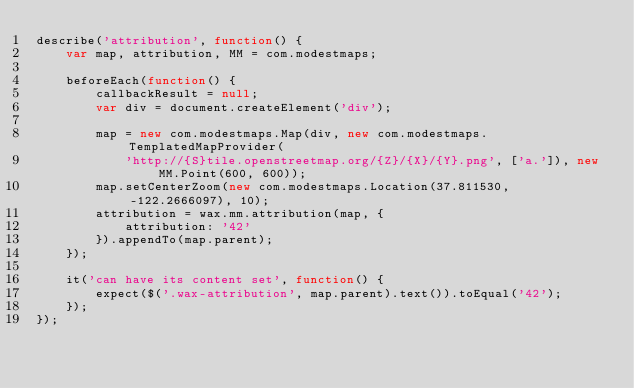Convert code to text. <code><loc_0><loc_0><loc_500><loc_500><_JavaScript_>describe('attribution', function() {
    var map, attribution, MM = com.modestmaps;

    beforeEach(function() {
        callbackResult = null;
        var div = document.createElement('div');

        map = new com.modestmaps.Map(div, new com.modestmaps.TemplatedMapProvider(
            'http://{S}tile.openstreetmap.org/{Z}/{X}/{Y}.png', ['a.']), new MM.Point(600, 600));
        map.setCenterZoom(new com.modestmaps.Location(37.811530, -122.2666097), 10);
        attribution = wax.mm.attribution(map, {
            attribution: '42'
        }).appendTo(map.parent);
    });

    it('can have its content set', function() {
        expect($('.wax-attribution', map.parent).text()).toEqual('42');
    });
});
</code> 